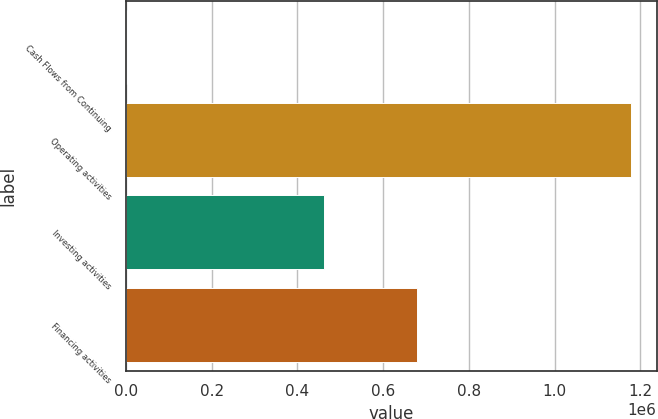Convert chart. <chart><loc_0><loc_0><loc_500><loc_500><bar_chart><fcel>Cash Flows from Continuing<fcel>Operating activities<fcel>Investing activities<fcel>Financing activities<nl><fcel>2013<fcel>1.17868e+06<fcel>463051<fcel>678542<nl></chart> 